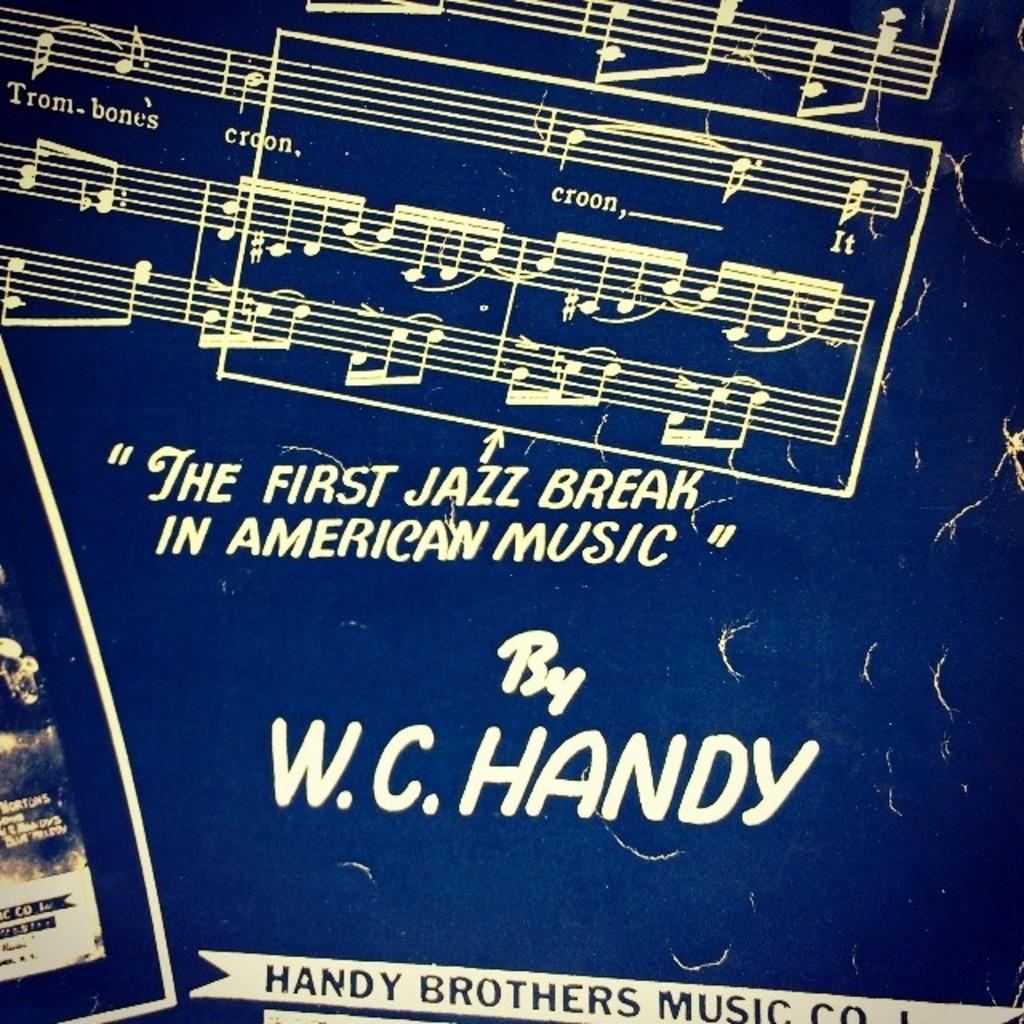What type of break is shown?
Give a very brief answer. Jazz. Who is this by?
Your answer should be very brief. W.c. handy. 